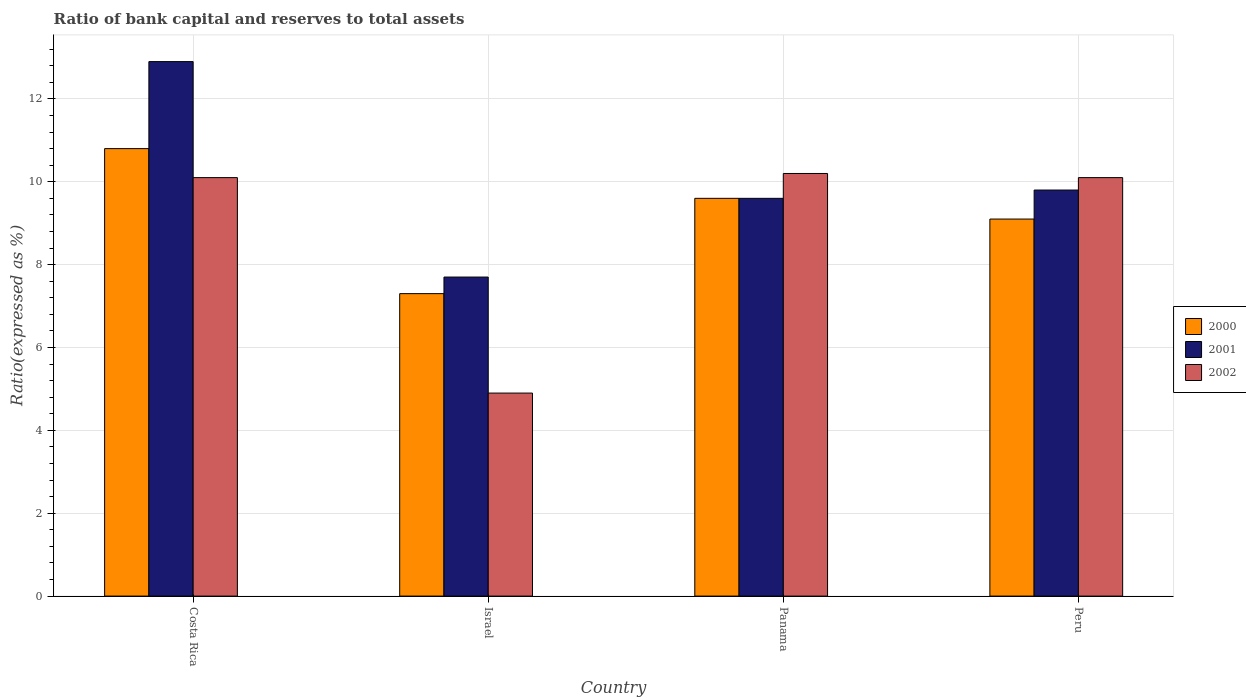How many different coloured bars are there?
Your response must be concise. 3. How many groups of bars are there?
Offer a very short reply. 4. What is the ratio of bank capital and reserves to total assets in 2001 in Panama?
Provide a succinct answer. 9.6. In which country was the ratio of bank capital and reserves to total assets in 2002 minimum?
Give a very brief answer. Israel. What is the total ratio of bank capital and reserves to total assets in 2001 in the graph?
Offer a very short reply. 40. What is the difference between the ratio of bank capital and reserves to total assets in 2001 in Costa Rica and that in Peru?
Your response must be concise. 3.1. What is the difference between the ratio of bank capital and reserves to total assets in 2000 in Peru and the ratio of bank capital and reserves to total assets in 2002 in Israel?
Ensure brevity in your answer.  4.2. What is the average ratio of bank capital and reserves to total assets in 2001 per country?
Keep it short and to the point. 10. What is the difference between the ratio of bank capital and reserves to total assets of/in 2000 and ratio of bank capital and reserves to total assets of/in 2002 in Costa Rica?
Make the answer very short. 0.7. In how many countries, is the ratio of bank capital and reserves to total assets in 2000 greater than 1.6 %?
Make the answer very short. 4. What is the ratio of the ratio of bank capital and reserves to total assets in 2000 in Panama to that in Peru?
Offer a terse response. 1.05. Is the ratio of bank capital and reserves to total assets in 2001 in Israel less than that in Peru?
Offer a very short reply. Yes. Is the difference between the ratio of bank capital and reserves to total assets in 2000 in Costa Rica and Peru greater than the difference between the ratio of bank capital and reserves to total assets in 2002 in Costa Rica and Peru?
Offer a terse response. Yes. What is the difference between the highest and the second highest ratio of bank capital and reserves to total assets in 2002?
Give a very brief answer. 0.1. What is the difference between the highest and the lowest ratio of bank capital and reserves to total assets in 2002?
Keep it short and to the point. 5.3. In how many countries, is the ratio of bank capital and reserves to total assets in 2002 greater than the average ratio of bank capital and reserves to total assets in 2002 taken over all countries?
Ensure brevity in your answer.  3. Is the sum of the ratio of bank capital and reserves to total assets in 2002 in Israel and Peru greater than the maximum ratio of bank capital and reserves to total assets in 2000 across all countries?
Make the answer very short. Yes. What does the 1st bar from the left in Israel represents?
Offer a very short reply. 2000. Is it the case that in every country, the sum of the ratio of bank capital and reserves to total assets in 2000 and ratio of bank capital and reserves to total assets in 2001 is greater than the ratio of bank capital and reserves to total assets in 2002?
Your answer should be compact. Yes. Are all the bars in the graph horizontal?
Offer a very short reply. No. What is the difference between two consecutive major ticks on the Y-axis?
Your response must be concise. 2. Are the values on the major ticks of Y-axis written in scientific E-notation?
Your answer should be very brief. No. Does the graph contain any zero values?
Provide a succinct answer. No. Does the graph contain grids?
Provide a succinct answer. Yes. How many legend labels are there?
Your response must be concise. 3. How are the legend labels stacked?
Give a very brief answer. Vertical. What is the title of the graph?
Provide a succinct answer. Ratio of bank capital and reserves to total assets. Does "2002" appear as one of the legend labels in the graph?
Provide a short and direct response. Yes. What is the label or title of the X-axis?
Your answer should be very brief. Country. What is the label or title of the Y-axis?
Keep it short and to the point. Ratio(expressed as %). What is the Ratio(expressed as %) in 2002 in Costa Rica?
Ensure brevity in your answer.  10.1. What is the Ratio(expressed as %) of 2000 in Israel?
Ensure brevity in your answer.  7.3. What is the Ratio(expressed as %) in 2002 in Israel?
Ensure brevity in your answer.  4.9. What is the Ratio(expressed as %) of 2001 in Panama?
Ensure brevity in your answer.  9.6. What is the Ratio(expressed as %) of 2002 in Panama?
Your response must be concise. 10.2. Across all countries, what is the maximum Ratio(expressed as %) in 2001?
Provide a short and direct response. 12.9. Across all countries, what is the minimum Ratio(expressed as %) in 2001?
Your response must be concise. 7.7. Across all countries, what is the minimum Ratio(expressed as %) of 2002?
Offer a very short reply. 4.9. What is the total Ratio(expressed as %) of 2000 in the graph?
Give a very brief answer. 36.8. What is the total Ratio(expressed as %) in 2001 in the graph?
Ensure brevity in your answer.  40. What is the total Ratio(expressed as %) in 2002 in the graph?
Your answer should be compact. 35.3. What is the difference between the Ratio(expressed as %) of 2000 in Costa Rica and that in Israel?
Your response must be concise. 3.5. What is the difference between the Ratio(expressed as %) of 2002 in Costa Rica and that in Israel?
Provide a succinct answer. 5.2. What is the difference between the Ratio(expressed as %) in 2001 in Costa Rica and that in Peru?
Ensure brevity in your answer.  3.1. What is the difference between the Ratio(expressed as %) of 2002 in Costa Rica and that in Peru?
Your response must be concise. 0. What is the difference between the Ratio(expressed as %) in 2001 in Israel and that in Panama?
Ensure brevity in your answer.  -1.9. What is the difference between the Ratio(expressed as %) of 2002 in Israel and that in Panama?
Your answer should be compact. -5.3. What is the difference between the Ratio(expressed as %) in 2002 in Israel and that in Peru?
Offer a terse response. -5.2. What is the difference between the Ratio(expressed as %) in 2001 in Panama and that in Peru?
Your answer should be compact. -0.2. What is the difference between the Ratio(expressed as %) in 2002 in Panama and that in Peru?
Make the answer very short. 0.1. What is the difference between the Ratio(expressed as %) of 2001 in Costa Rica and the Ratio(expressed as %) of 2002 in Israel?
Ensure brevity in your answer.  8. What is the difference between the Ratio(expressed as %) of 2000 in Costa Rica and the Ratio(expressed as %) of 2001 in Panama?
Provide a succinct answer. 1.2. What is the difference between the Ratio(expressed as %) of 2000 in Israel and the Ratio(expressed as %) of 2001 in Panama?
Give a very brief answer. -2.3. What is the difference between the Ratio(expressed as %) in 2000 in Israel and the Ratio(expressed as %) in 2002 in Panama?
Provide a short and direct response. -2.9. What is the difference between the Ratio(expressed as %) of 2001 in Israel and the Ratio(expressed as %) of 2002 in Peru?
Your answer should be compact. -2.4. What is the difference between the Ratio(expressed as %) of 2000 in Panama and the Ratio(expressed as %) of 2001 in Peru?
Your answer should be compact. -0.2. What is the difference between the Ratio(expressed as %) in 2001 in Panama and the Ratio(expressed as %) in 2002 in Peru?
Offer a very short reply. -0.5. What is the average Ratio(expressed as %) in 2002 per country?
Give a very brief answer. 8.82. What is the difference between the Ratio(expressed as %) in 2000 and Ratio(expressed as %) in 2002 in Costa Rica?
Provide a succinct answer. 0.7. What is the difference between the Ratio(expressed as %) of 2000 and Ratio(expressed as %) of 2001 in Israel?
Your answer should be very brief. -0.4. What is the difference between the Ratio(expressed as %) in 2000 and Ratio(expressed as %) in 2002 in Israel?
Your response must be concise. 2.4. What is the difference between the Ratio(expressed as %) in 2000 and Ratio(expressed as %) in 2001 in Panama?
Offer a very short reply. 0. What is the difference between the Ratio(expressed as %) of 2000 and Ratio(expressed as %) of 2001 in Peru?
Make the answer very short. -0.7. What is the difference between the Ratio(expressed as %) in 2001 and Ratio(expressed as %) in 2002 in Peru?
Your response must be concise. -0.3. What is the ratio of the Ratio(expressed as %) of 2000 in Costa Rica to that in Israel?
Offer a terse response. 1.48. What is the ratio of the Ratio(expressed as %) of 2001 in Costa Rica to that in Israel?
Your answer should be compact. 1.68. What is the ratio of the Ratio(expressed as %) of 2002 in Costa Rica to that in Israel?
Provide a short and direct response. 2.06. What is the ratio of the Ratio(expressed as %) in 2001 in Costa Rica to that in Panama?
Provide a succinct answer. 1.34. What is the ratio of the Ratio(expressed as %) in 2002 in Costa Rica to that in Panama?
Keep it short and to the point. 0.99. What is the ratio of the Ratio(expressed as %) in 2000 in Costa Rica to that in Peru?
Give a very brief answer. 1.19. What is the ratio of the Ratio(expressed as %) in 2001 in Costa Rica to that in Peru?
Your answer should be very brief. 1.32. What is the ratio of the Ratio(expressed as %) of 2000 in Israel to that in Panama?
Your answer should be compact. 0.76. What is the ratio of the Ratio(expressed as %) of 2001 in Israel to that in Panama?
Your answer should be compact. 0.8. What is the ratio of the Ratio(expressed as %) of 2002 in Israel to that in Panama?
Keep it short and to the point. 0.48. What is the ratio of the Ratio(expressed as %) of 2000 in Israel to that in Peru?
Your response must be concise. 0.8. What is the ratio of the Ratio(expressed as %) in 2001 in Israel to that in Peru?
Give a very brief answer. 0.79. What is the ratio of the Ratio(expressed as %) in 2002 in Israel to that in Peru?
Provide a short and direct response. 0.49. What is the ratio of the Ratio(expressed as %) in 2000 in Panama to that in Peru?
Offer a very short reply. 1.05. What is the ratio of the Ratio(expressed as %) of 2001 in Panama to that in Peru?
Offer a terse response. 0.98. What is the ratio of the Ratio(expressed as %) in 2002 in Panama to that in Peru?
Make the answer very short. 1.01. What is the difference between the highest and the second highest Ratio(expressed as %) in 2001?
Offer a very short reply. 3.1. What is the difference between the highest and the lowest Ratio(expressed as %) in 2001?
Give a very brief answer. 5.2. What is the difference between the highest and the lowest Ratio(expressed as %) in 2002?
Keep it short and to the point. 5.3. 